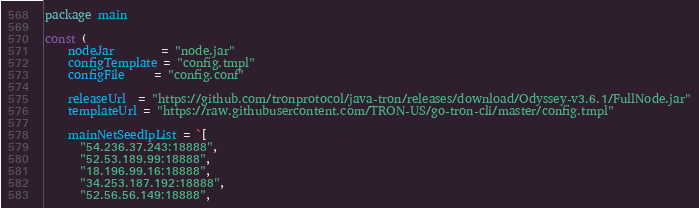<code> <loc_0><loc_0><loc_500><loc_500><_Go_>package main

const (
	nodeJar        = "node.jar"
	configTemplate = "config.tmpl"
	configFile     = "config.conf"

	releaseUrl  = "https://github.com/tronprotocol/java-tron/releases/download/Odyssey-v3.6.1/FullNode.jar"
	templateUrl = "https://raw.githubusercontent.com/TRON-US/go-tron-cli/master/config.tmpl"

	mainNetSeedIpList = `[
      "54.236.37.243:18888",
      "52.53.189.99:18888",
      "18.196.99.16:18888",
      "34.253.187.192:18888",
      "52.56.56.149:18888",</code> 